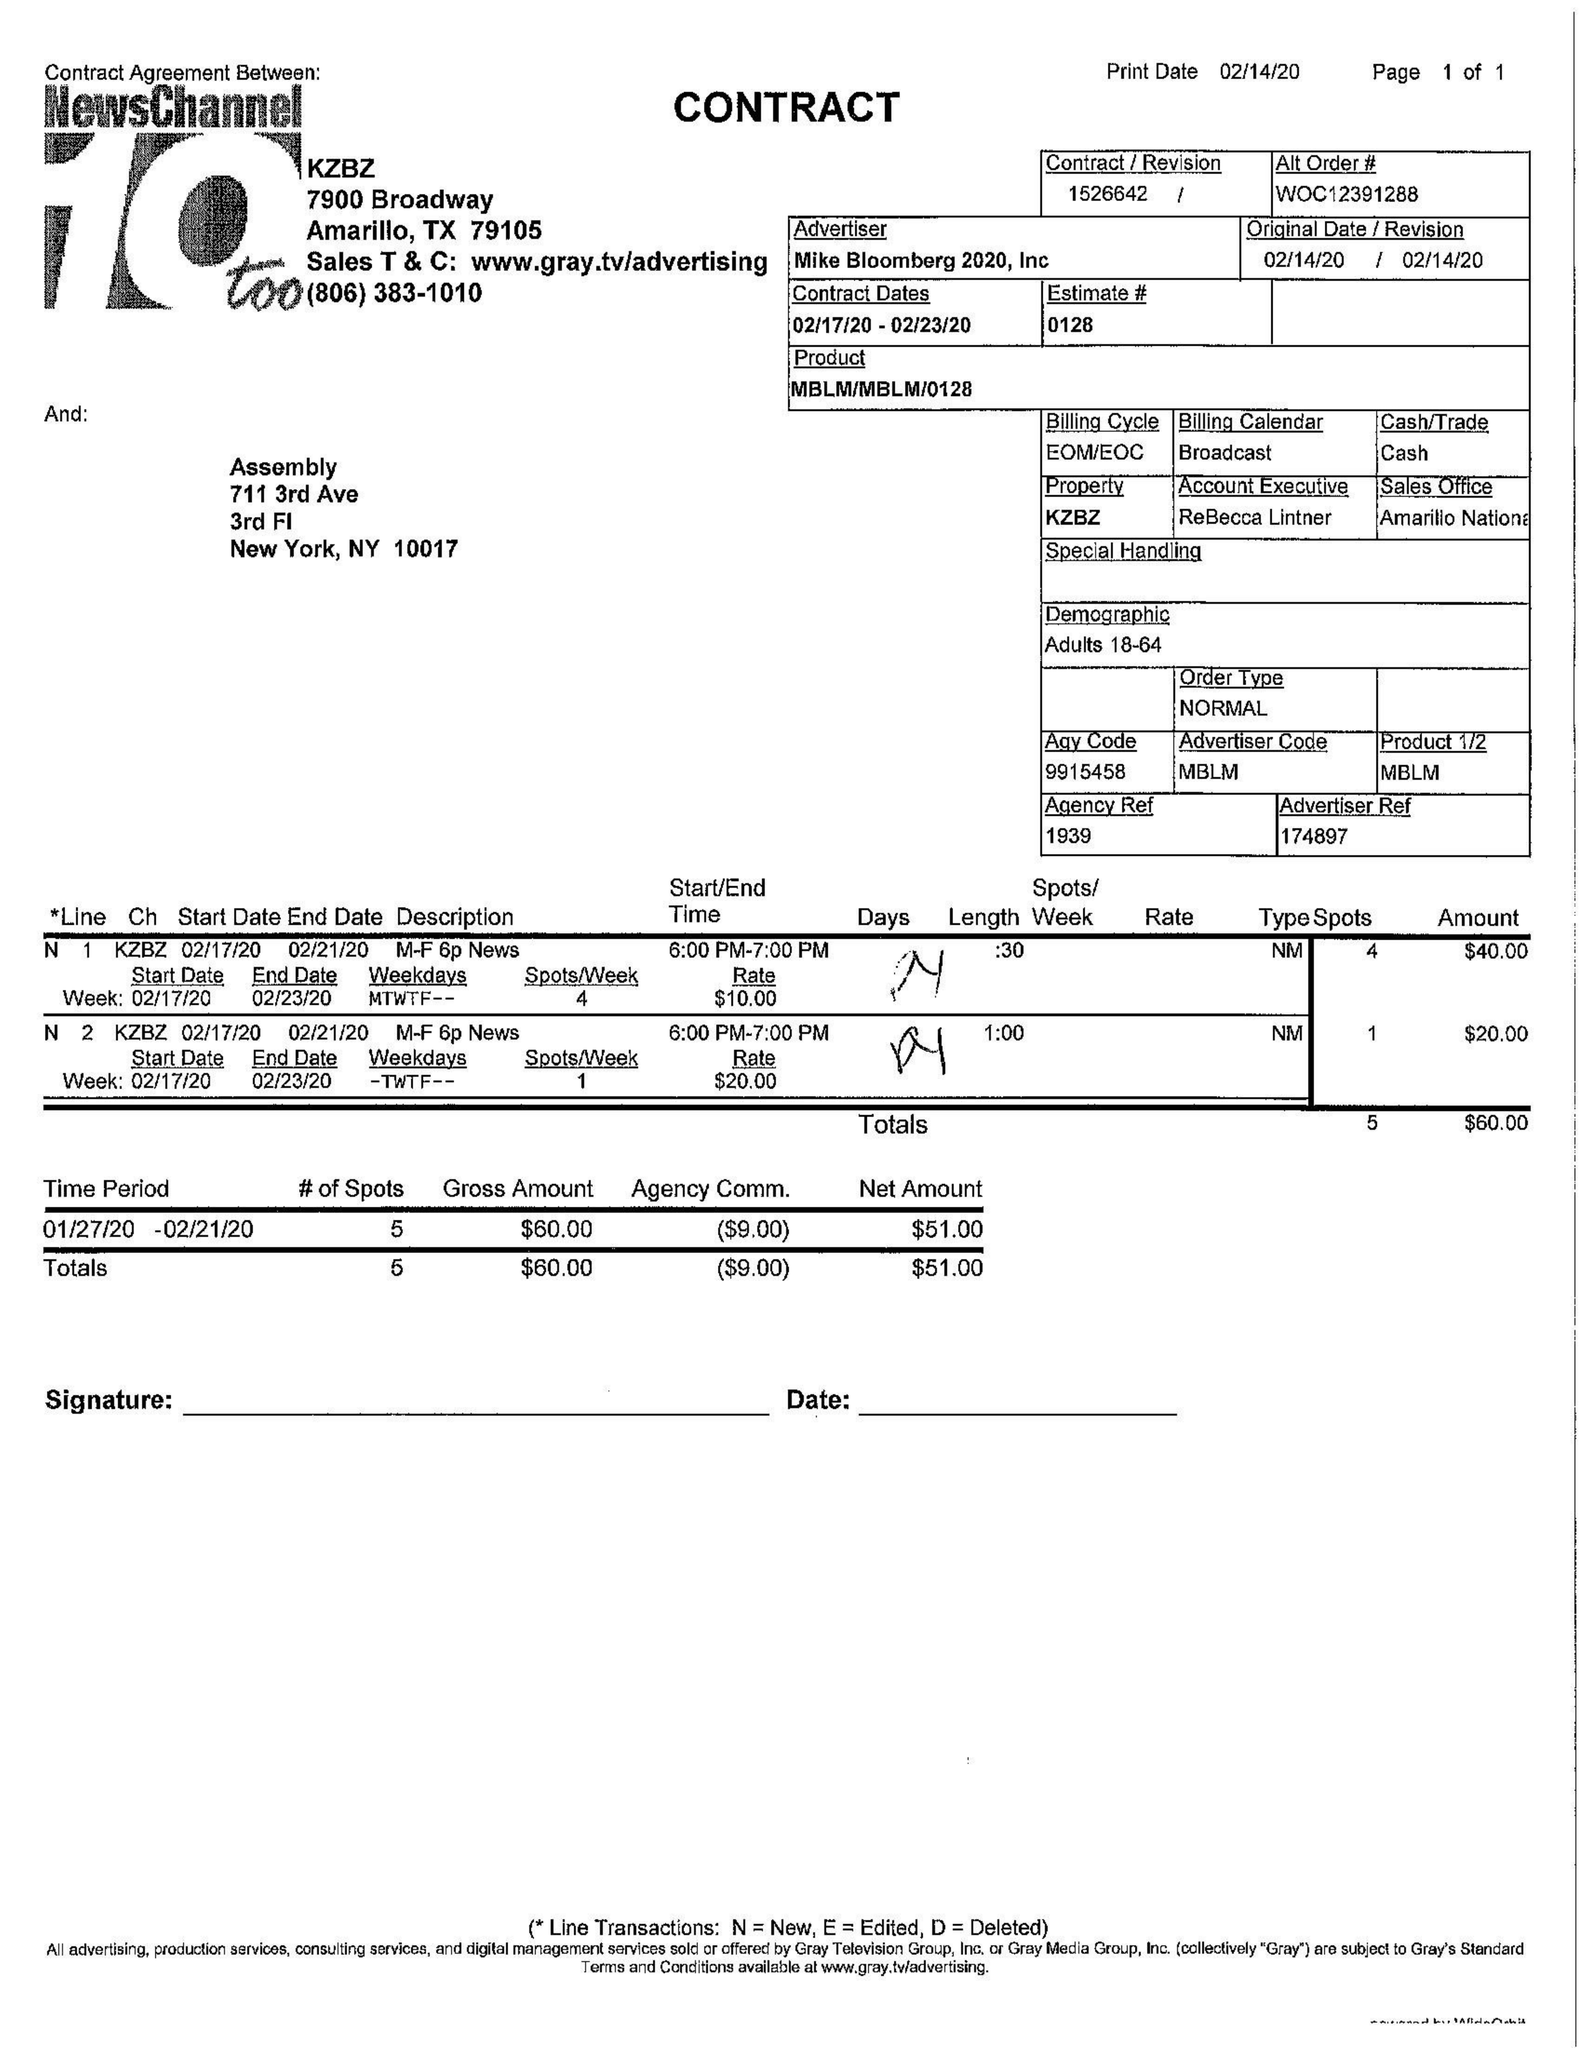What is the value for the contract_num?
Answer the question using a single word or phrase. 1526642 